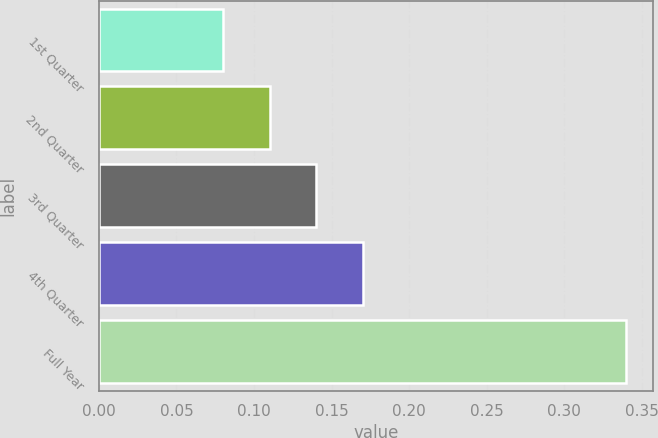Convert chart. <chart><loc_0><loc_0><loc_500><loc_500><bar_chart><fcel>1st Quarter<fcel>2nd Quarter<fcel>3rd Quarter<fcel>4th Quarter<fcel>Full Year<nl><fcel>0.08<fcel>0.11<fcel>0.14<fcel>0.17<fcel>0.34<nl></chart> 